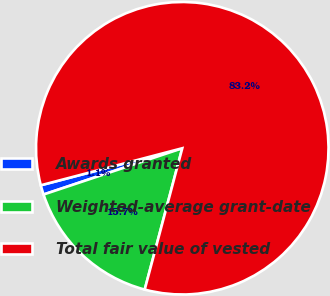Convert chart. <chart><loc_0><loc_0><loc_500><loc_500><pie_chart><fcel>Awards granted<fcel>Weighted-average grant-date<fcel>Total fair value of vested<nl><fcel>1.05%<fcel>15.74%<fcel>83.2%<nl></chart> 